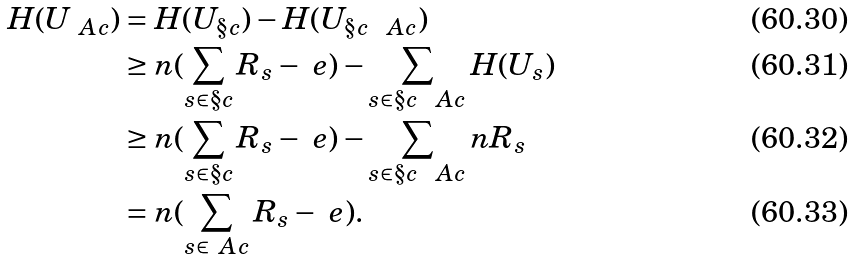Convert formula to latex. <formula><loc_0><loc_0><loc_500><loc_500>H ( U _ { \ A c } ) & = H ( U _ { \S c } ) - H ( U _ { \S c \ \ A c } ) \\ & \geq n ( \sum _ { s \in \S c } R _ { s } - \ e ) - \sum _ { s \in \S c \ \ A c } H ( U _ { s } ) \\ & \geq n ( \sum _ { s \in \S c } R _ { s } - \ e ) - \sum _ { s \in \S c \ \ A c } n R _ { s } \\ & = n ( \sum _ { s \in \ A c } R _ { s } - \ e ) .</formula> 